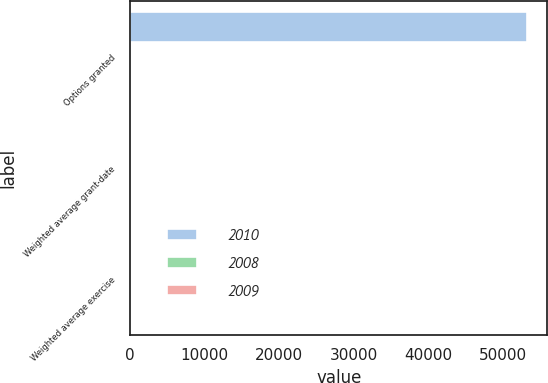<chart> <loc_0><loc_0><loc_500><loc_500><stacked_bar_chart><ecel><fcel>Options granted<fcel>Weighted average grant-date<fcel>Weighted average exercise<nl><fcel>2010<fcel>53304<fcel>10<fcel>18<nl><fcel>2008<fcel>0<fcel>0<fcel>0<nl><fcel>2009<fcel>11<fcel>12<fcel>31<nl></chart> 